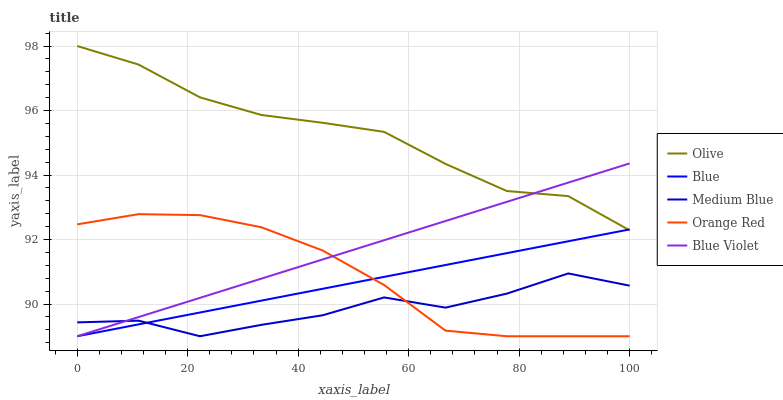Does Medium Blue have the minimum area under the curve?
Answer yes or no. Yes. Does Olive have the maximum area under the curve?
Answer yes or no. Yes. Does Blue have the minimum area under the curve?
Answer yes or no. No. Does Blue have the maximum area under the curve?
Answer yes or no. No. Is Blue the smoothest?
Answer yes or no. Yes. Is Medium Blue the roughest?
Answer yes or no. Yes. Is Medium Blue the smoothest?
Answer yes or no. No. Is Blue the roughest?
Answer yes or no. No. Does Blue have the lowest value?
Answer yes or no. Yes. Does Olive have the highest value?
Answer yes or no. Yes. Does Blue have the highest value?
Answer yes or no. No. Is Medium Blue less than Olive?
Answer yes or no. Yes. Is Olive greater than Orange Red?
Answer yes or no. Yes. Does Blue intersect Medium Blue?
Answer yes or no. Yes. Is Blue less than Medium Blue?
Answer yes or no. No. Is Blue greater than Medium Blue?
Answer yes or no. No. Does Medium Blue intersect Olive?
Answer yes or no. No. 